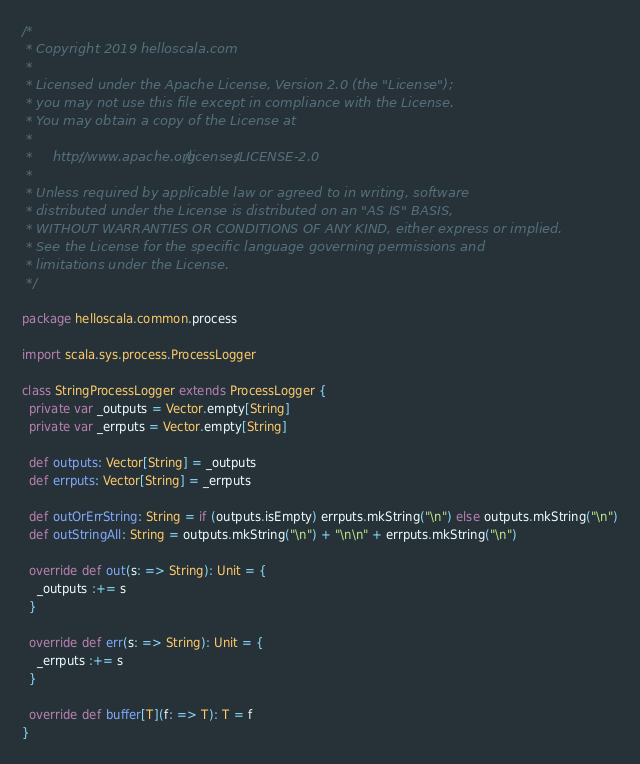Convert code to text. <code><loc_0><loc_0><loc_500><loc_500><_Scala_>/*
 * Copyright 2019 helloscala.com
 *
 * Licensed under the Apache License, Version 2.0 (the "License");
 * you may not use this file except in compliance with the License.
 * You may obtain a copy of the License at
 *
 *     http://www.apache.org/licenses/LICENSE-2.0
 *
 * Unless required by applicable law or agreed to in writing, software
 * distributed under the License is distributed on an "AS IS" BASIS,
 * WITHOUT WARRANTIES OR CONDITIONS OF ANY KIND, either express or implied.
 * See the License for the specific language governing permissions and
 * limitations under the License.
 */

package helloscala.common.process

import scala.sys.process.ProcessLogger

class StringProcessLogger extends ProcessLogger {
  private var _outputs = Vector.empty[String]
  private var _errputs = Vector.empty[String]

  def outputs: Vector[String] = _outputs
  def errputs: Vector[String] = _errputs

  def outOrErrString: String = if (outputs.isEmpty) errputs.mkString("\n") else outputs.mkString("\n")
  def outStringAll: String = outputs.mkString("\n") + "\n\n" + errputs.mkString("\n")

  override def out(s: => String): Unit = {
    _outputs :+= s
  }

  override def err(s: => String): Unit = {
    _errputs :+= s
  }

  override def buffer[T](f: => T): T = f
}
</code> 